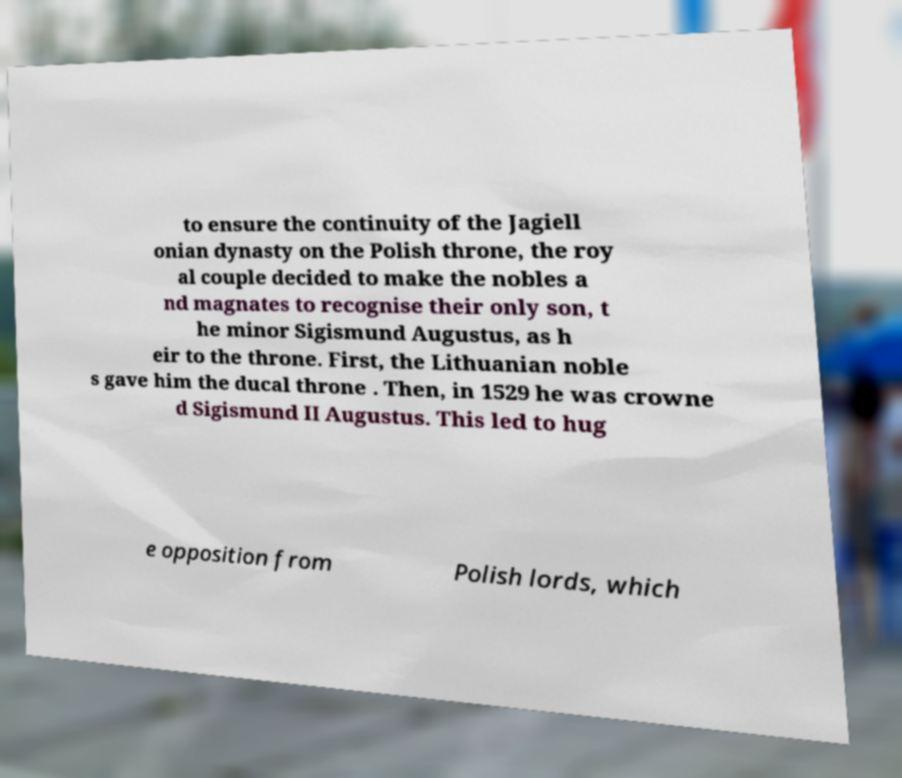Please read and relay the text visible in this image. What does it say? to ensure the continuity of the Jagiell onian dynasty on the Polish throne, the roy al couple decided to make the nobles a nd magnates to recognise their only son, t he minor Sigismund Augustus, as h eir to the throne. First, the Lithuanian noble s gave him the ducal throne . Then, in 1529 he was crowne d Sigismund II Augustus. This led to hug e opposition from Polish lords, which 